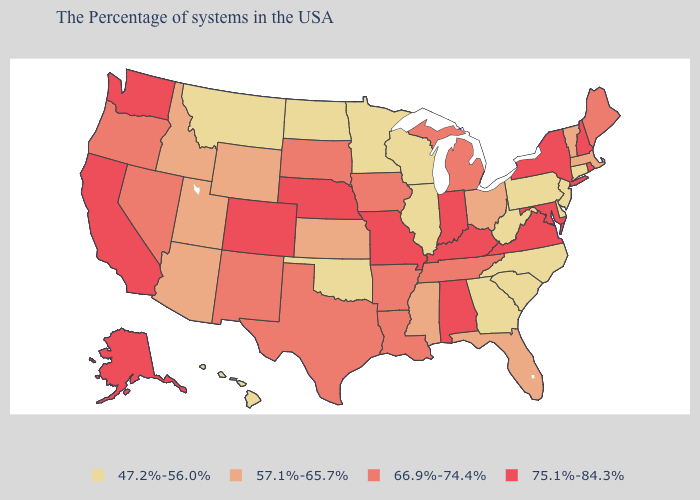Name the states that have a value in the range 75.1%-84.3%?
Write a very short answer. Rhode Island, New Hampshire, New York, Maryland, Virginia, Kentucky, Indiana, Alabama, Missouri, Nebraska, Colorado, California, Washington, Alaska. What is the highest value in the MidWest ?
Concise answer only. 75.1%-84.3%. Among the states that border California , which have the highest value?
Answer briefly. Nevada, Oregon. Which states have the highest value in the USA?
Give a very brief answer. Rhode Island, New Hampshire, New York, Maryland, Virginia, Kentucky, Indiana, Alabama, Missouri, Nebraska, Colorado, California, Washington, Alaska. Name the states that have a value in the range 75.1%-84.3%?
Keep it brief. Rhode Island, New Hampshire, New York, Maryland, Virginia, Kentucky, Indiana, Alabama, Missouri, Nebraska, Colorado, California, Washington, Alaska. Does the map have missing data?
Quick response, please. No. What is the value of Maine?
Be succinct. 66.9%-74.4%. What is the value of Washington?
Answer briefly. 75.1%-84.3%. Is the legend a continuous bar?
Keep it brief. No. What is the value of Kentucky?
Concise answer only. 75.1%-84.3%. Does the map have missing data?
Write a very short answer. No. Name the states that have a value in the range 47.2%-56.0%?
Answer briefly. Connecticut, New Jersey, Delaware, Pennsylvania, North Carolina, South Carolina, West Virginia, Georgia, Wisconsin, Illinois, Minnesota, Oklahoma, North Dakota, Montana, Hawaii. What is the value of Georgia?
Concise answer only. 47.2%-56.0%. Does Vermont have a higher value than Iowa?
Answer briefly. No. 